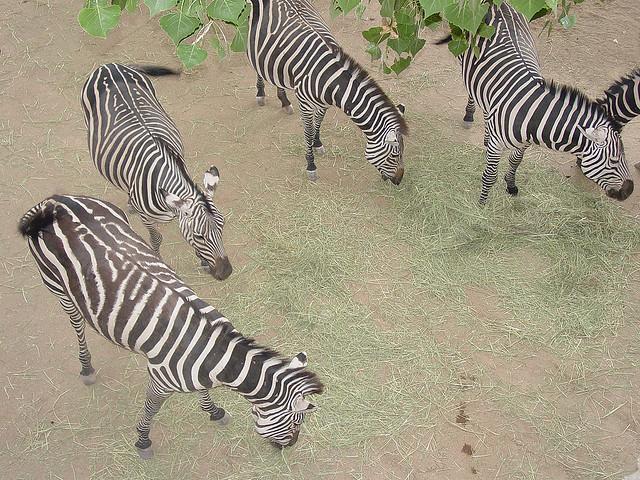How many zebras are standing on the hay below the tree?
Make your selection from the four choices given to correctly answer the question.
Options: Four, five, one, three. Four. 